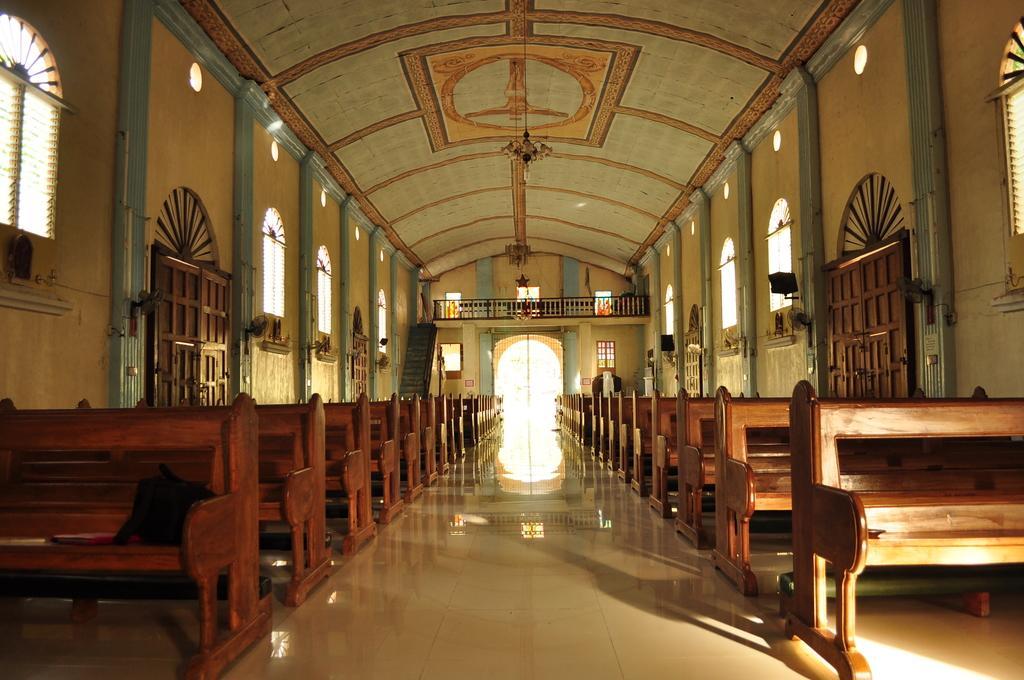Describe this image in one or two sentences. It looks like a church there are many benches to sit and around the benches there are few doors and windows. 